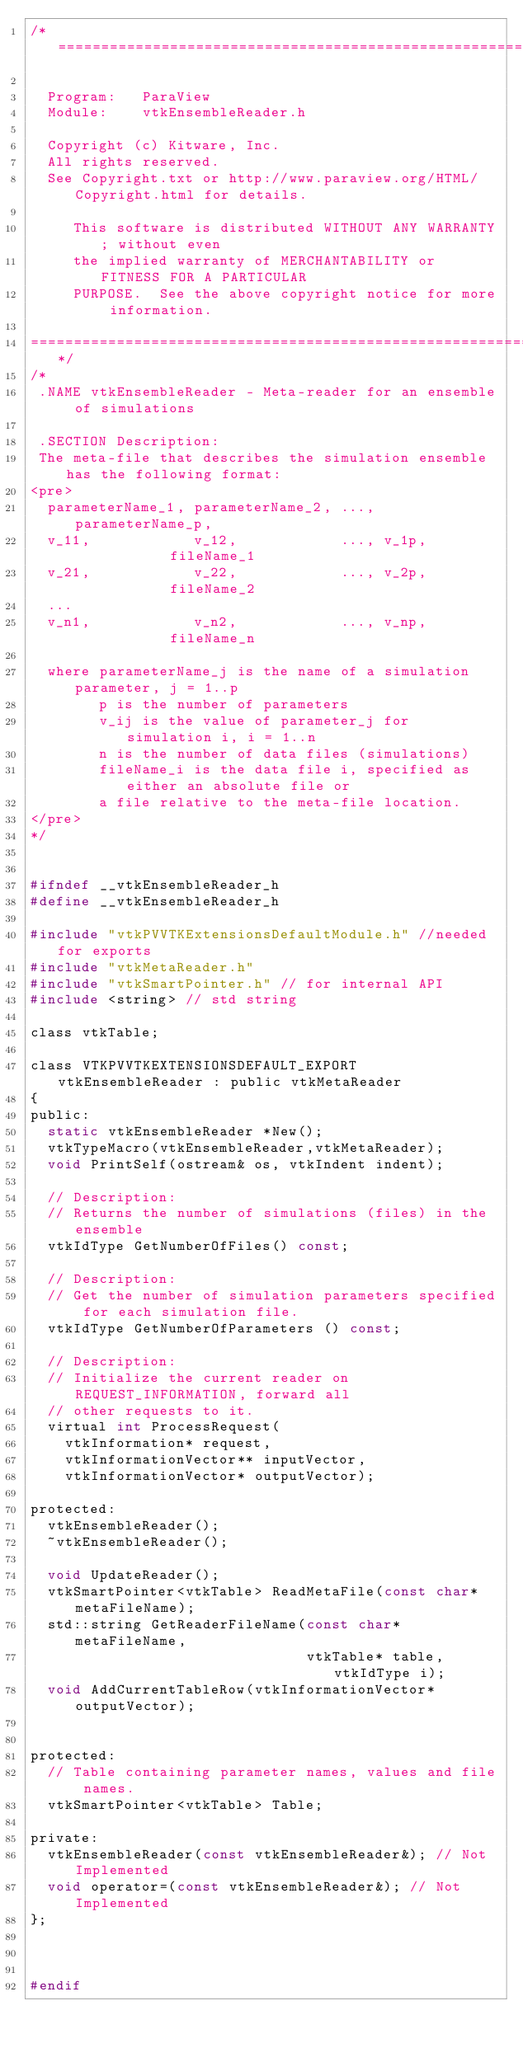<code> <loc_0><loc_0><loc_500><loc_500><_C_>/*=========================================================================

  Program:   ParaView
  Module:    vtkEnsembleReader.h

  Copyright (c) Kitware, Inc.
  All rights reserved.
  See Copyright.txt or http://www.paraview.org/HTML/Copyright.html for details.

     This software is distributed WITHOUT ANY WARRANTY; without even
     the implied warranty of MERCHANTABILITY or FITNESS FOR A PARTICULAR
     PURPOSE.  See the above copyright notice for more information.

=========================================================================*/
/*
 .NAME vtkEnsembleReader - Meta-reader for an ensemble of simulations

 .SECTION Description:
 The meta-file that describes the simulation ensemble has the following format:
<pre>
  parameterName_1, parameterName_2, ..., parameterName_p,
  v_11,            v_12,            ..., v_1p,            fileName_1
  v_21,            v_22,            ..., v_2p,            fileName_2
  ...
  v_n1,            v_n2,            ..., v_np,            fileName_n

  where parameterName_j is the name of a simulation parameter, j = 1..p
        p is the number of parameters
        v_ij is the value of parameter_j for simulation i, i = 1..n
        n is the number of data files (simulations)
        fileName_i is the data file i, specified as either an absolute file or
        a file relative to the meta-file location.
</pre>
*/


#ifndef __vtkEnsembleReader_h
#define __vtkEnsembleReader_h

#include "vtkPVVTKExtensionsDefaultModule.h" //needed for exports
#include "vtkMetaReader.h"
#include "vtkSmartPointer.h" // for internal API
#include <string> // std string

class vtkTable;

class VTKPVVTKEXTENSIONSDEFAULT_EXPORT vtkEnsembleReader : public vtkMetaReader
{
public:
  static vtkEnsembleReader *New();
  vtkTypeMacro(vtkEnsembleReader,vtkMetaReader);
  void PrintSelf(ostream& os, vtkIndent indent);

  // Description:
  // Returns the number of simulations (files) in the ensemble
  vtkIdType GetNumberOfFiles() const;

  // Description:
  // Get the number of simulation parameters specified for each simulation file.
  vtkIdType GetNumberOfParameters () const;

  // Description:
  // Initialize the current reader on REQUEST_INFORMATION, forward all
  // other requests to it.
  virtual int ProcessRequest(
    vtkInformation* request,
    vtkInformationVector** inputVector,
    vtkInformationVector* outputVector);

protected:
  vtkEnsembleReader();
  ~vtkEnsembleReader();

  void UpdateReader();
  vtkSmartPointer<vtkTable> ReadMetaFile(const char* metaFileName);
  std::string GetReaderFileName(const char* metaFileName,
                                vtkTable* table, vtkIdType i);
  void AddCurrentTableRow(vtkInformationVector* outputVector);


protected:
  // Table containing parameter names, values and file names.
  vtkSmartPointer<vtkTable> Table;

private:
  vtkEnsembleReader(const vtkEnsembleReader&); // Not Implemented
  void operator=(const vtkEnsembleReader&); // Not Implemented
};



#endif
</code> 